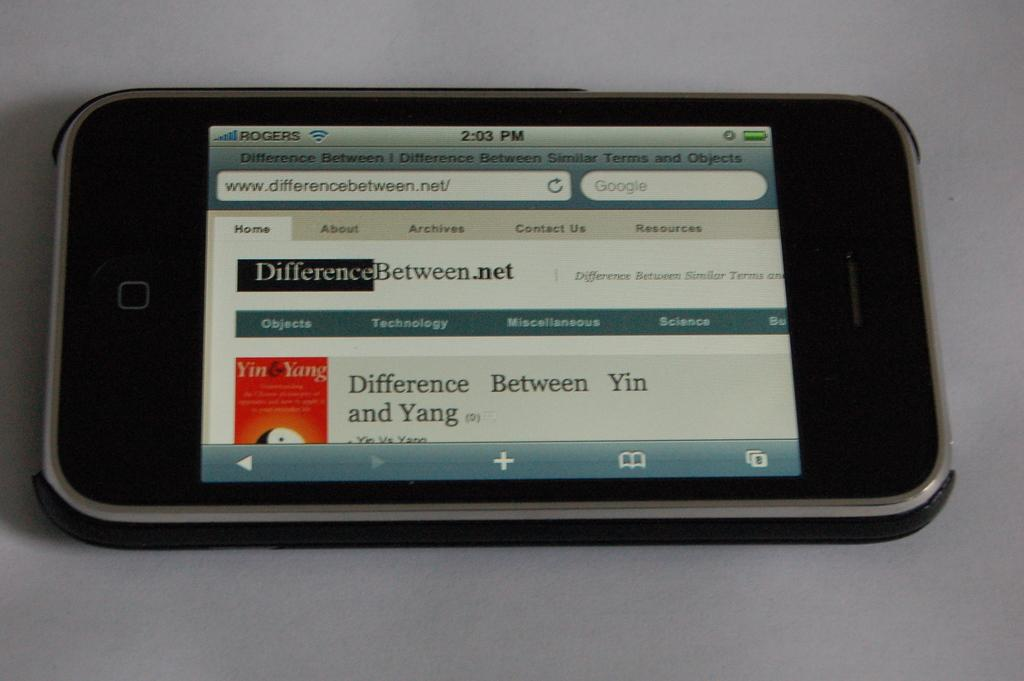<image>
Write a terse but informative summary of the picture. Iphone is by itself with a website called differencebeween.net 